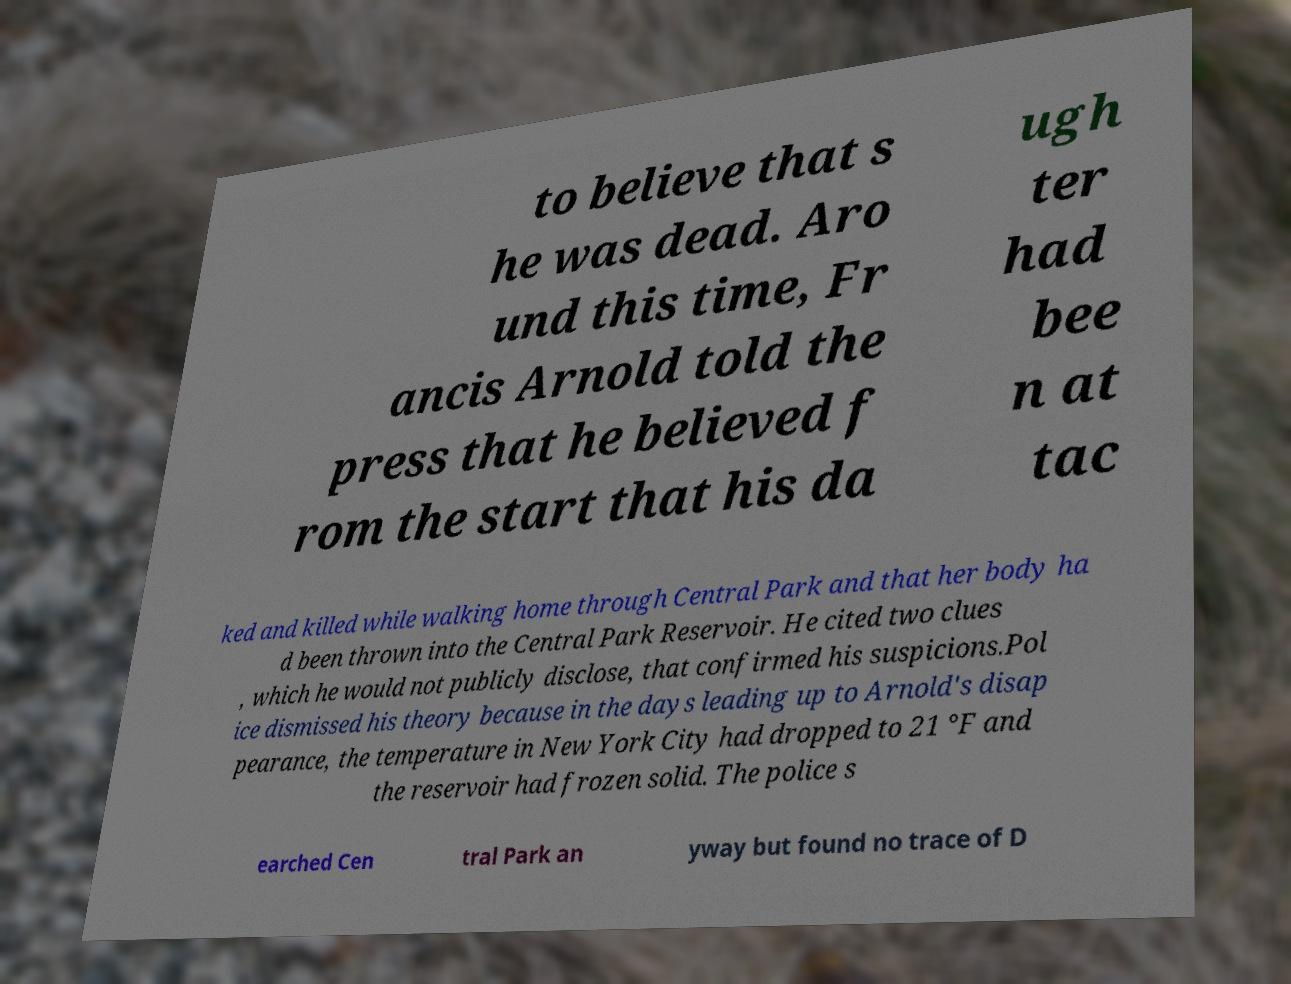What messages or text are displayed in this image? I need them in a readable, typed format. to believe that s he was dead. Aro und this time, Fr ancis Arnold told the press that he believed f rom the start that his da ugh ter had bee n at tac ked and killed while walking home through Central Park and that her body ha d been thrown into the Central Park Reservoir. He cited two clues , which he would not publicly disclose, that confirmed his suspicions.Pol ice dismissed his theory because in the days leading up to Arnold's disap pearance, the temperature in New York City had dropped to 21 °F and the reservoir had frozen solid. The police s earched Cen tral Park an yway but found no trace of D 